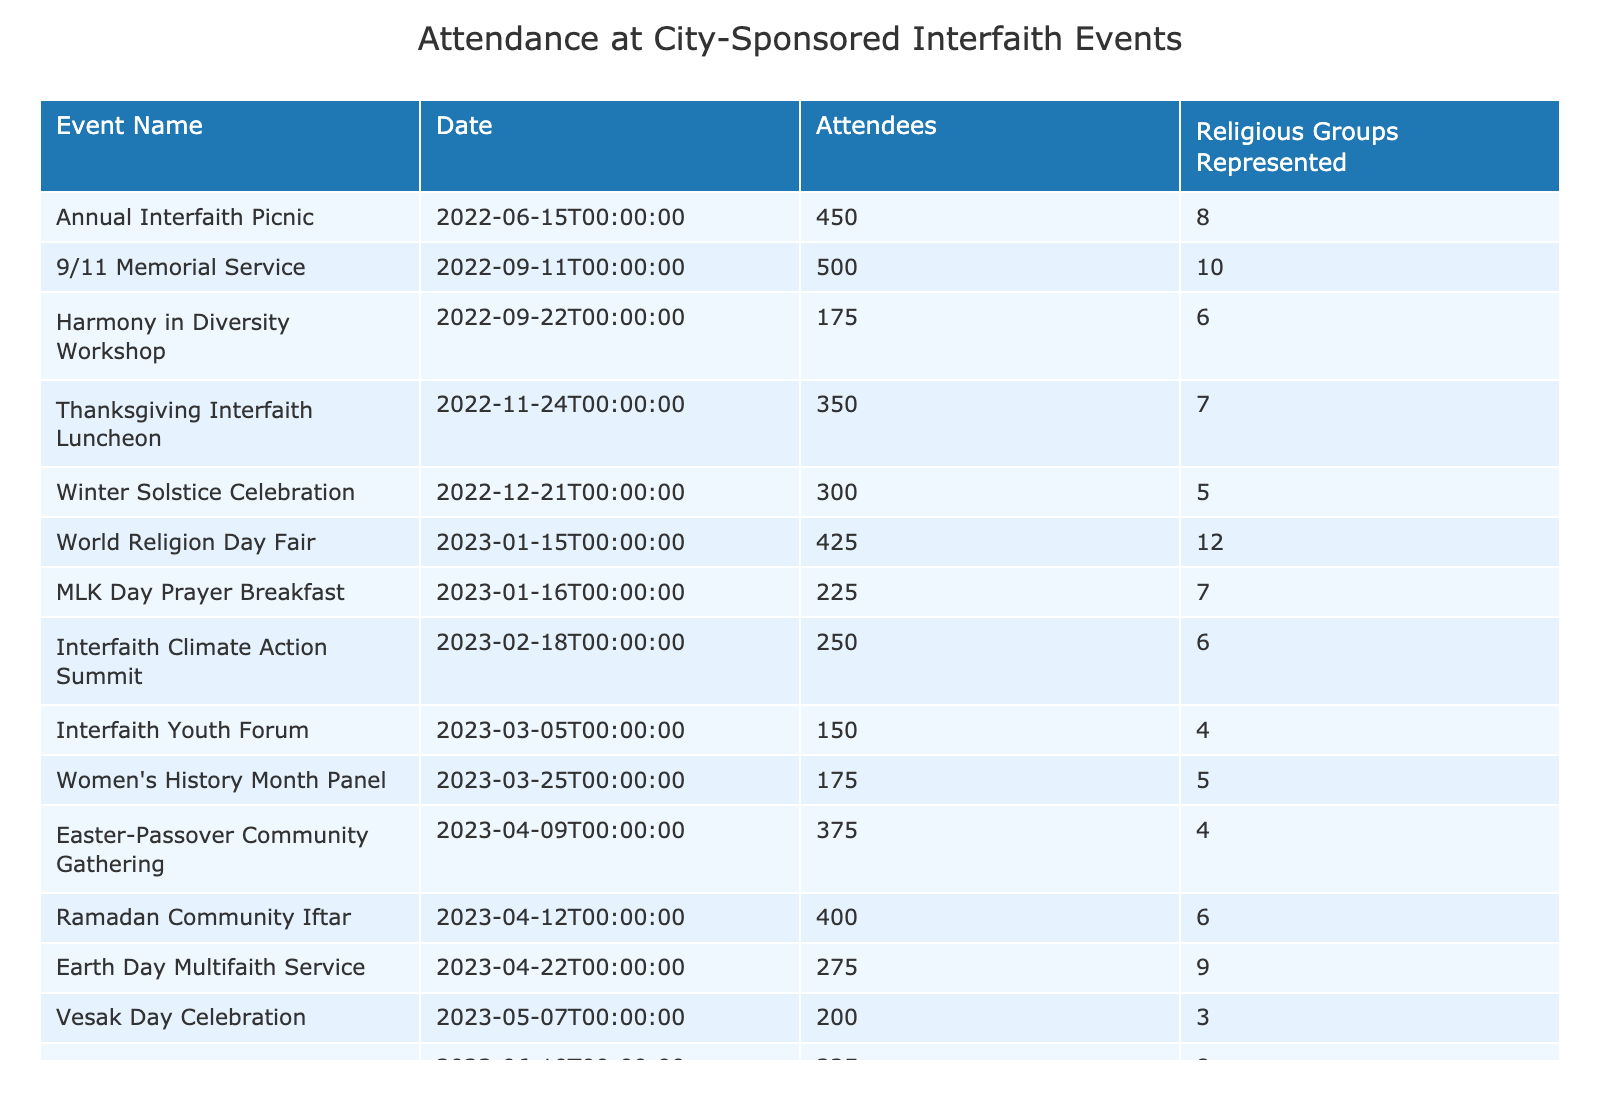What is the event with the highest attendance? By reviewing the "Attendees" column in the table, we can see that the "9/11 Memorial Service" has the highest number of attendees, which is 500.
Answer: 9/11 Memorial Service How many religious groups were represented at the "World Religion Day Fair"? The "World Religion Day Fair" has 12 religious groups represented, as indicated in the "Religious Groups Represented" column.
Answer: 12 What is the total attendance at interfaith events held in 2023? Adding up the attendees from events in 2023: 225 (MLK Day) + 150 (Interfaith Youth Forum) + 400 (Ramadan Iftar) + 200 (Vesak Day) + 325 (Pride Month) + 425 (World Religion Day) + 250 (Climate Action) + 175 (Women's History) + 375 (Easter-Passover) equals 2,100.
Answer: 2100 Was there an event in 2022 that had more than 400 attendees? Yes, the "9/11 Memorial Service" with 500 attendees and the "Annual Interfaith Picnic" with 450 attendees both confirmed this condition in 2022.
Answer: Yes What is the average number of attendees across all events? To calculate the average, sum all attendees (450 + 175 + 300 + 225 + 150 + 275 + 400 + 200 + 325 + 500 + 350 + 425 + 250 + 175 + 375 = 4,225), then divide by the number of events (15): 4225 / 15 = 281.67.
Answer: 281.67 How many events had more than 6 religious groups represented? By examining the "Religious Groups Represented" column, we can identify three events: "9/11 Memorial Service" (10), "World Religion Day Fair" (12), and "Earth Day Multifaith Service" (9).
Answer: 3 What is the difference in attendance between the event with the highest and the event with the lowest attendance? The highest attendance was at the "9/11 Memorial Service" with 500 attendees, and the lowest was at the "Interfaith Youth Forum" with 150 attendees. The difference is 500 - 150 = 350.
Answer: 350 Which month had the highest number of attendees across its events? Analyzing the events in each month: January (650), March (325), April (775), June (325), and so forth. The month with the maximum total is April, with the combined attendance of 275 (Earth Day) + 400 (Ramadan Iftar) + 375 (Easter-Passover) = 1,050.
Answer: April How many events were held after January 2023? Observing the dates, there are seven events that took place after January 2023: March (2 events), April (3 events), and June (1 event). Thus, counting them provides a total of 7 events.
Answer: 7 What proportion of events had less than 200 attendees? Out of the 15 events, four had less than 200 attendees: "Harmony in Diversity Workshop" (175), "Interfaith Youth Forum" (150), "Vesak Day Celebration" (200), and "Women's History Month Panel" (175). To find the proportion: 4 events / 15 total events = 0.267, or approximately 27%.
Answer: 26.67% 